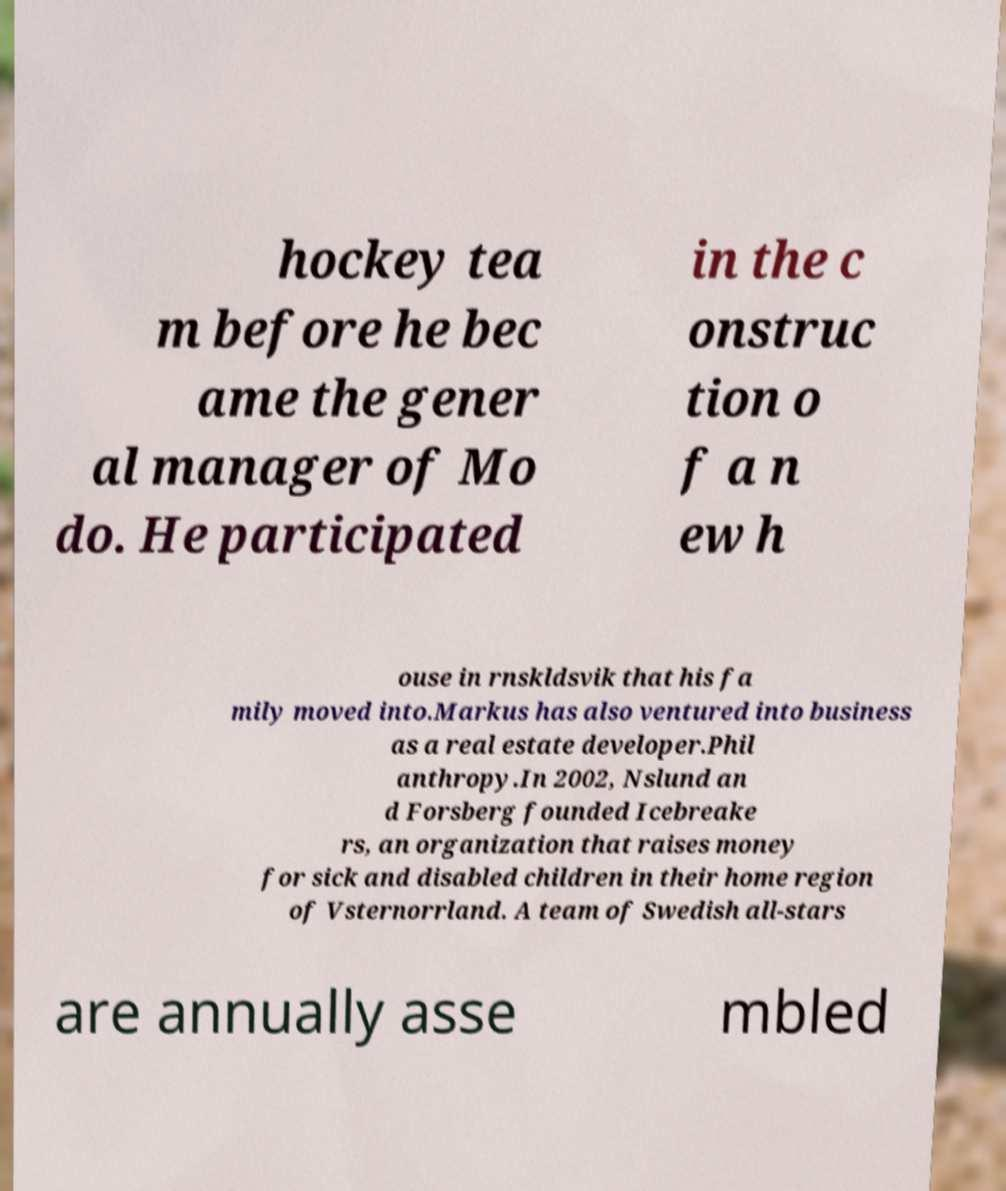Can you accurately transcribe the text from the provided image for me? hockey tea m before he bec ame the gener al manager of Mo do. He participated in the c onstruc tion o f a n ew h ouse in rnskldsvik that his fa mily moved into.Markus has also ventured into business as a real estate developer.Phil anthropy.In 2002, Nslund an d Forsberg founded Icebreake rs, an organization that raises money for sick and disabled children in their home region of Vsternorrland. A team of Swedish all-stars are annually asse mbled 